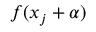<formula> <loc_0><loc_0><loc_500><loc_500>f ( x _ { j } + \alpha )</formula> 